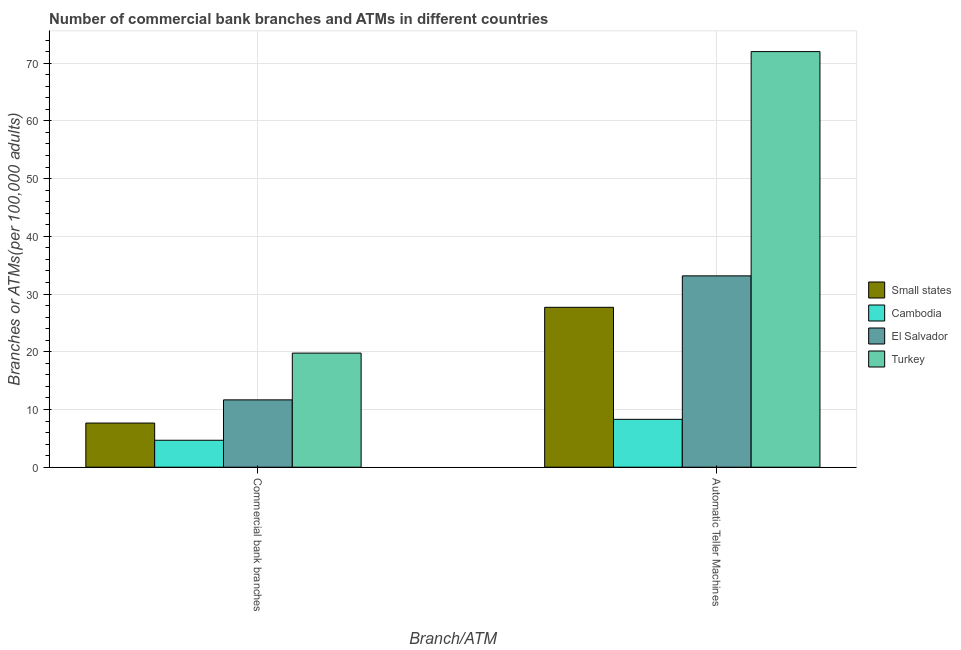How many groups of bars are there?
Make the answer very short. 2. Are the number of bars on each tick of the X-axis equal?
Make the answer very short. Yes. How many bars are there on the 2nd tick from the left?
Ensure brevity in your answer.  4. What is the label of the 2nd group of bars from the left?
Your response must be concise. Automatic Teller Machines. What is the number of commercal bank branches in El Salvador?
Give a very brief answer. 11.67. Across all countries, what is the maximum number of atms?
Your response must be concise. 72. Across all countries, what is the minimum number of atms?
Your answer should be compact. 8.29. In which country was the number of commercal bank branches maximum?
Offer a terse response. Turkey. In which country was the number of commercal bank branches minimum?
Give a very brief answer. Cambodia. What is the total number of commercal bank branches in the graph?
Your response must be concise. 43.75. What is the difference between the number of commercal bank branches in Cambodia and that in Small states?
Your response must be concise. -2.98. What is the difference between the number of commercal bank branches in Small states and the number of atms in Turkey?
Your response must be concise. -64.35. What is the average number of commercal bank branches per country?
Give a very brief answer. 10.94. What is the difference between the number of atms and number of commercal bank branches in Turkey?
Your response must be concise. 52.23. What is the ratio of the number of commercal bank branches in Turkey to that in Small states?
Provide a short and direct response. 2.58. Is the number of atms in Turkey less than that in El Salvador?
Provide a succinct answer. No. In how many countries, is the number of atms greater than the average number of atms taken over all countries?
Provide a succinct answer. 1. What does the 4th bar from the left in Automatic Teller Machines represents?
Provide a succinct answer. Turkey. What does the 4th bar from the right in Automatic Teller Machines represents?
Your response must be concise. Small states. How many bars are there?
Offer a terse response. 8. How many countries are there in the graph?
Your answer should be very brief. 4. Does the graph contain grids?
Offer a terse response. Yes. How many legend labels are there?
Keep it short and to the point. 4. How are the legend labels stacked?
Your response must be concise. Vertical. What is the title of the graph?
Keep it short and to the point. Number of commercial bank branches and ATMs in different countries. What is the label or title of the X-axis?
Ensure brevity in your answer.  Branch/ATM. What is the label or title of the Y-axis?
Offer a terse response. Branches or ATMs(per 100,0 adults). What is the Branches or ATMs(per 100,000 adults) of Small states in Commercial bank branches?
Provide a short and direct response. 7.65. What is the Branches or ATMs(per 100,000 adults) in Cambodia in Commercial bank branches?
Provide a succinct answer. 4.67. What is the Branches or ATMs(per 100,000 adults) of El Salvador in Commercial bank branches?
Keep it short and to the point. 11.67. What is the Branches or ATMs(per 100,000 adults) of Turkey in Commercial bank branches?
Ensure brevity in your answer.  19.77. What is the Branches or ATMs(per 100,000 adults) in Small states in Automatic Teller Machines?
Your answer should be very brief. 27.7. What is the Branches or ATMs(per 100,000 adults) of Cambodia in Automatic Teller Machines?
Offer a very short reply. 8.29. What is the Branches or ATMs(per 100,000 adults) in El Salvador in Automatic Teller Machines?
Keep it short and to the point. 33.15. What is the Branches or ATMs(per 100,000 adults) in Turkey in Automatic Teller Machines?
Keep it short and to the point. 72. Across all Branch/ATM, what is the maximum Branches or ATMs(per 100,000 adults) in Small states?
Provide a succinct answer. 27.7. Across all Branch/ATM, what is the maximum Branches or ATMs(per 100,000 adults) of Cambodia?
Provide a short and direct response. 8.29. Across all Branch/ATM, what is the maximum Branches or ATMs(per 100,000 adults) of El Salvador?
Provide a short and direct response. 33.15. Across all Branch/ATM, what is the maximum Branches or ATMs(per 100,000 adults) of Turkey?
Give a very brief answer. 72. Across all Branch/ATM, what is the minimum Branches or ATMs(per 100,000 adults) of Small states?
Your answer should be very brief. 7.65. Across all Branch/ATM, what is the minimum Branches or ATMs(per 100,000 adults) of Cambodia?
Ensure brevity in your answer.  4.67. Across all Branch/ATM, what is the minimum Branches or ATMs(per 100,000 adults) in El Salvador?
Your answer should be compact. 11.67. Across all Branch/ATM, what is the minimum Branches or ATMs(per 100,000 adults) in Turkey?
Make the answer very short. 19.77. What is the total Branches or ATMs(per 100,000 adults) in Small states in the graph?
Offer a terse response. 35.35. What is the total Branches or ATMs(per 100,000 adults) in Cambodia in the graph?
Ensure brevity in your answer.  12.96. What is the total Branches or ATMs(per 100,000 adults) of El Salvador in the graph?
Give a very brief answer. 44.81. What is the total Branches or ATMs(per 100,000 adults) of Turkey in the graph?
Give a very brief answer. 91.77. What is the difference between the Branches or ATMs(per 100,000 adults) in Small states in Commercial bank branches and that in Automatic Teller Machines?
Ensure brevity in your answer.  -20.05. What is the difference between the Branches or ATMs(per 100,000 adults) in Cambodia in Commercial bank branches and that in Automatic Teller Machines?
Give a very brief answer. -3.62. What is the difference between the Branches or ATMs(per 100,000 adults) in El Salvador in Commercial bank branches and that in Automatic Teller Machines?
Your response must be concise. -21.48. What is the difference between the Branches or ATMs(per 100,000 adults) of Turkey in Commercial bank branches and that in Automatic Teller Machines?
Make the answer very short. -52.23. What is the difference between the Branches or ATMs(per 100,000 adults) in Small states in Commercial bank branches and the Branches or ATMs(per 100,000 adults) in Cambodia in Automatic Teller Machines?
Your answer should be compact. -0.64. What is the difference between the Branches or ATMs(per 100,000 adults) in Small states in Commercial bank branches and the Branches or ATMs(per 100,000 adults) in El Salvador in Automatic Teller Machines?
Offer a terse response. -25.5. What is the difference between the Branches or ATMs(per 100,000 adults) of Small states in Commercial bank branches and the Branches or ATMs(per 100,000 adults) of Turkey in Automatic Teller Machines?
Your answer should be compact. -64.35. What is the difference between the Branches or ATMs(per 100,000 adults) in Cambodia in Commercial bank branches and the Branches or ATMs(per 100,000 adults) in El Salvador in Automatic Teller Machines?
Provide a succinct answer. -28.48. What is the difference between the Branches or ATMs(per 100,000 adults) of Cambodia in Commercial bank branches and the Branches or ATMs(per 100,000 adults) of Turkey in Automatic Teller Machines?
Your answer should be compact. -67.33. What is the difference between the Branches or ATMs(per 100,000 adults) of El Salvador in Commercial bank branches and the Branches or ATMs(per 100,000 adults) of Turkey in Automatic Teller Machines?
Make the answer very short. -60.34. What is the average Branches or ATMs(per 100,000 adults) of Small states per Branch/ATM?
Provide a short and direct response. 17.68. What is the average Branches or ATMs(per 100,000 adults) in Cambodia per Branch/ATM?
Give a very brief answer. 6.48. What is the average Branches or ATMs(per 100,000 adults) of El Salvador per Branch/ATM?
Give a very brief answer. 22.41. What is the average Branches or ATMs(per 100,000 adults) of Turkey per Branch/ATM?
Offer a very short reply. 45.89. What is the difference between the Branches or ATMs(per 100,000 adults) of Small states and Branches or ATMs(per 100,000 adults) of Cambodia in Commercial bank branches?
Ensure brevity in your answer.  2.98. What is the difference between the Branches or ATMs(per 100,000 adults) of Small states and Branches or ATMs(per 100,000 adults) of El Salvador in Commercial bank branches?
Offer a very short reply. -4.02. What is the difference between the Branches or ATMs(per 100,000 adults) of Small states and Branches or ATMs(per 100,000 adults) of Turkey in Commercial bank branches?
Offer a very short reply. -12.12. What is the difference between the Branches or ATMs(per 100,000 adults) in Cambodia and Branches or ATMs(per 100,000 adults) in El Salvador in Commercial bank branches?
Ensure brevity in your answer.  -7. What is the difference between the Branches or ATMs(per 100,000 adults) in Cambodia and Branches or ATMs(per 100,000 adults) in Turkey in Commercial bank branches?
Make the answer very short. -15.1. What is the difference between the Branches or ATMs(per 100,000 adults) in El Salvador and Branches or ATMs(per 100,000 adults) in Turkey in Commercial bank branches?
Your response must be concise. -8.1. What is the difference between the Branches or ATMs(per 100,000 adults) in Small states and Branches or ATMs(per 100,000 adults) in Cambodia in Automatic Teller Machines?
Make the answer very short. 19.41. What is the difference between the Branches or ATMs(per 100,000 adults) in Small states and Branches or ATMs(per 100,000 adults) in El Salvador in Automatic Teller Machines?
Your answer should be very brief. -5.45. What is the difference between the Branches or ATMs(per 100,000 adults) in Small states and Branches or ATMs(per 100,000 adults) in Turkey in Automatic Teller Machines?
Your answer should be very brief. -44.3. What is the difference between the Branches or ATMs(per 100,000 adults) in Cambodia and Branches or ATMs(per 100,000 adults) in El Salvador in Automatic Teller Machines?
Make the answer very short. -24.86. What is the difference between the Branches or ATMs(per 100,000 adults) in Cambodia and Branches or ATMs(per 100,000 adults) in Turkey in Automatic Teller Machines?
Provide a succinct answer. -63.71. What is the difference between the Branches or ATMs(per 100,000 adults) of El Salvador and Branches or ATMs(per 100,000 adults) of Turkey in Automatic Teller Machines?
Make the answer very short. -38.85. What is the ratio of the Branches or ATMs(per 100,000 adults) of Small states in Commercial bank branches to that in Automatic Teller Machines?
Your answer should be very brief. 0.28. What is the ratio of the Branches or ATMs(per 100,000 adults) of Cambodia in Commercial bank branches to that in Automatic Teller Machines?
Keep it short and to the point. 0.56. What is the ratio of the Branches or ATMs(per 100,000 adults) of El Salvador in Commercial bank branches to that in Automatic Teller Machines?
Your response must be concise. 0.35. What is the ratio of the Branches or ATMs(per 100,000 adults) in Turkey in Commercial bank branches to that in Automatic Teller Machines?
Offer a terse response. 0.27. What is the difference between the highest and the second highest Branches or ATMs(per 100,000 adults) of Small states?
Give a very brief answer. 20.05. What is the difference between the highest and the second highest Branches or ATMs(per 100,000 adults) in Cambodia?
Your answer should be very brief. 3.62. What is the difference between the highest and the second highest Branches or ATMs(per 100,000 adults) of El Salvador?
Your response must be concise. 21.48. What is the difference between the highest and the second highest Branches or ATMs(per 100,000 adults) in Turkey?
Offer a terse response. 52.23. What is the difference between the highest and the lowest Branches or ATMs(per 100,000 adults) of Small states?
Your answer should be very brief. 20.05. What is the difference between the highest and the lowest Branches or ATMs(per 100,000 adults) in Cambodia?
Provide a short and direct response. 3.62. What is the difference between the highest and the lowest Branches or ATMs(per 100,000 adults) in El Salvador?
Your answer should be compact. 21.48. What is the difference between the highest and the lowest Branches or ATMs(per 100,000 adults) of Turkey?
Your answer should be compact. 52.23. 